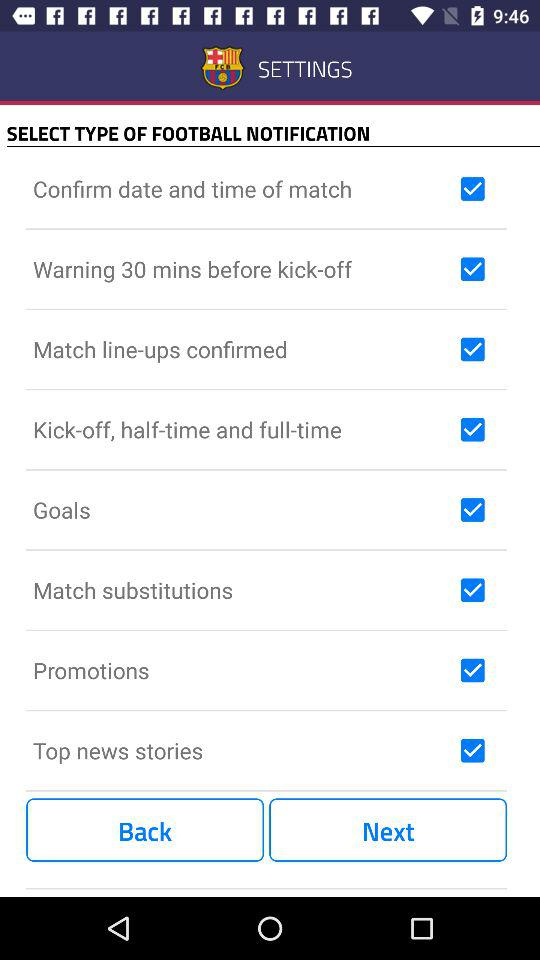What is the status of "Goals"? The status is "on". 